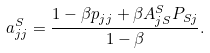<formula> <loc_0><loc_0><loc_500><loc_500>a _ { j j } ^ { S } = \frac { 1 - \beta p _ { j j } + \beta A _ { j S } ^ { S } P _ { S j } } { 1 - \beta } .</formula> 